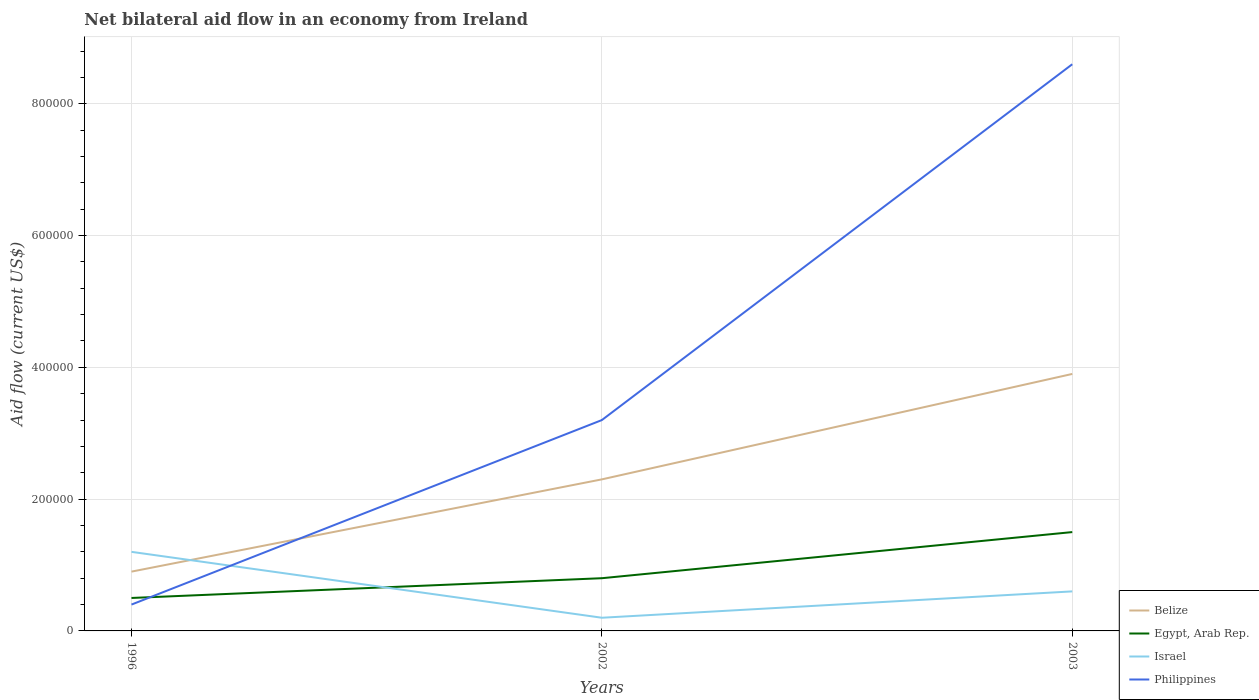Is the number of lines equal to the number of legend labels?
Offer a very short reply. Yes. What is the difference between the highest and the second highest net bilateral aid flow in Egypt, Arab Rep.?
Provide a succinct answer. 1.00e+05. What is the difference between the highest and the lowest net bilateral aid flow in Israel?
Ensure brevity in your answer.  1. How many lines are there?
Your answer should be compact. 4. Are the values on the major ticks of Y-axis written in scientific E-notation?
Ensure brevity in your answer.  No. Does the graph contain any zero values?
Make the answer very short. No. Does the graph contain grids?
Your response must be concise. Yes. How many legend labels are there?
Provide a short and direct response. 4. What is the title of the graph?
Give a very brief answer. Net bilateral aid flow in an economy from Ireland. Does "Caribbean small states" appear as one of the legend labels in the graph?
Make the answer very short. No. What is the Aid flow (current US$) in Philippines in 1996?
Keep it short and to the point. 4.00e+04. What is the Aid flow (current US$) of Egypt, Arab Rep. in 2002?
Ensure brevity in your answer.  8.00e+04. What is the Aid flow (current US$) of Israel in 2002?
Your answer should be compact. 2.00e+04. What is the Aid flow (current US$) in Belize in 2003?
Keep it short and to the point. 3.90e+05. What is the Aid flow (current US$) of Israel in 2003?
Provide a succinct answer. 6.00e+04. What is the Aid flow (current US$) in Philippines in 2003?
Your response must be concise. 8.60e+05. Across all years, what is the maximum Aid flow (current US$) of Belize?
Offer a very short reply. 3.90e+05. Across all years, what is the maximum Aid flow (current US$) of Egypt, Arab Rep.?
Offer a very short reply. 1.50e+05. Across all years, what is the maximum Aid flow (current US$) in Israel?
Offer a terse response. 1.20e+05. Across all years, what is the maximum Aid flow (current US$) in Philippines?
Offer a very short reply. 8.60e+05. Across all years, what is the minimum Aid flow (current US$) of Belize?
Your answer should be very brief. 9.00e+04. Across all years, what is the minimum Aid flow (current US$) in Israel?
Offer a very short reply. 2.00e+04. Across all years, what is the minimum Aid flow (current US$) of Philippines?
Your answer should be very brief. 4.00e+04. What is the total Aid flow (current US$) in Belize in the graph?
Provide a short and direct response. 7.10e+05. What is the total Aid flow (current US$) of Israel in the graph?
Give a very brief answer. 2.00e+05. What is the total Aid flow (current US$) in Philippines in the graph?
Make the answer very short. 1.22e+06. What is the difference between the Aid flow (current US$) in Israel in 1996 and that in 2002?
Your answer should be very brief. 1.00e+05. What is the difference between the Aid flow (current US$) of Philippines in 1996 and that in 2002?
Your answer should be compact. -2.80e+05. What is the difference between the Aid flow (current US$) in Egypt, Arab Rep. in 1996 and that in 2003?
Offer a terse response. -1.00e+05. What is the difference between the Aid flow (current US$) in Israel in 1996 and that in 2003?
Your answer should be very brief. 6.00e+04. What is the difference between the Aid flow (current US$) in Philippines in 1996 and that in 2003?
Offer a terse response. -8.20e+05. What is the difference between the Aid flow (current US$) in Belize in 2002 and that in 2003?
Provide a short and direct response. -1.60e+05. What is the difference between the Aid flow (current US$) in Philippines in 2002 and that in 2003?
Provide a short and direct response. -5.40e+05. What is the difference between the Aid flow (current US$) of Belize in 1996 and the Aid flow (current US$) of Egypt, Arab Rep. in 2002?
Provide a succinct answer. 10000. What is the difference between the Aid flow (current US$) in Belize in 1996 and the Aid flow (current US$) in Philippines in 2002?
Give a very brief answer. -2.30e+05. What is the difference between the Aid flow (current US$) of Egypt, Arab Rep. in 1996 and the Aid flow (current US$) of Philippines in 2002?
Offer a very short reply. -2.70e+05. What is the difference between the Aid flow (current US$) in Belize in 1996 and the Aid flow (current US$) in Egypt, Arab Rep. in 2003?
Give a very brief answer. -6.00e+04. What is the difference between the Aid flow (current US$) of Belize in 1996 and the Aid flow (current US$) of Philippines in 2003?
Offer a very short reply. -7.70e+05. What is the difference between the Aid flow (current US$) of Egypt, Arab Rep. in 1996 and the Aid flow (current US$) of Israel in 2003?
Keep it short and to the point. -10000. What is the difference between the Aid flow (current US$) of Egypt, Arab Rep. in 1996 and the Aid flow (current US$) of Philippines in 2003?
Provide a succinct answer. -8.10e+05. What is the difference between the Aid flow (current US$) in Israel in 1996 and the Aid flow (current US$) in Philippines in 2003?
Keep it short and to the point. -7.40e+05. What is the difference between the Aid flow (current US$) in Belize in 2002 and the Aid flow (current US$) in Israel in 2003?
Keep it short and to the point. 1.70e+05. What is the difference between the Aid flow (current US$) in Belize in 2002 and the Aid flow (current US$) in Philippines in 2003?
Provide a short and direct response. -6.30e+05. What is the difference between the Aid flow (current US$) of Egypt, Arab Rep. in 2002 and the Aid flow (current US$) of Israel in 2003?
Your answer should be very brief. 2.00e+04. What is the difference between the Aid flow (current US$) of Egypt, Arab Rep. in 2002 and the Aid flow (current US$) of Philippines in 2003?
Provide a succinct answer. -7.80e+05. What is the difference between the Aid flow (current US$) in Israel in 2002 and the Aid flow (current US$) in Philippines in 2003?
Make the answer very short. -8.40e+05. What is the average Aid flow (current US$) of Belize per year?
Provide a short and direct response. 2.37e+05. What is the average Aid flow (current US$) of Egypt, Arab Rep. per year?
Keep it short and to the point. 9.33e+04. What is the average Aid flow (current US$) of Israel per year?
Make the answer very short. 6.67e+04. What is the average Aid flow (current US$) in Philippines per year?
Offer a terse response. 4.07e+05. In the year 1996, what is the difference between the Aid flow (current US$) in Belize and Aid flow (current US$) in Egypt, Arab Rep.?
Give a very brief answer. 4.00e+04. In the year 1996, what is the difference between the Aid flow (current US$) in Egypt, Arab Rep. and Aid flow (current US$) in Israel?
Offer a very short reply. -7.00e+04. In the year 1996, what is the difference between the Aid flow (current US$) in Egypt, Arab Rep. and Aid flow (current US$) in Philippines?
Your answer should be very brief. 10000. In the year 2002, what is the difference between the Aid flow (current US$) in Belize and Aid flow (current US$) in Egypt, Arab Rep.?
Provide a succinct answer. 1.50e+05. In the year 2002, what is the difference between the Aid flow (current US$) in Belize and Aid flow (current US$) in Israel?
Your response must be concise. 2.10e+05. In the year 2002, what is the difference between the Aid flow (current US$) in Belize and Aid flow (current US$) in Philippines?
Your answer should be compact. -9.00e+04. In the year 2002, what is the difference between the Aid flow (current US$) of Egypt, Arab Rep. and Aid flow (current US$) of Israel?
Give a very brief answer. 6.00e+04. In the year 2002, what is the difference between the Aid flow (current US$) in Israel and Aid flow (current US$) in Philippines?
Offer a terse response. -3.00e+05. In the year 2003, what is the difference between the Aid flow (current US$) of Belize and Aid flow (current US$) of Egypt, Arab Rep.?
Offer a very short reply. 2.40e+05. In the year 2003, what is the difference between the Aid flow (current US$) of Belize and Aid flow (current US$) of Israel?
Provide a short and direct response. 3.30e+05. In the year 2003, what is the difference between the Aid flow (current US$) in Belize and Aid flow (current US$) in Philippines?
Provide a short and direct response. -4.70e+05. In the year 2003, what is the difference between the Aid flow (current US$) of Egypt, Arab Rep. and Aid flow (current US$) of Philippines?
Offer a very short reply. -7.10e+05. In the year 2003, what is the difference between the Aid flow (current US$) of Israel and Aid flow (current US$) of Philippines?
Your response must be concise. -8.00e+05. What is the ratio of the Aid flow (current US$) in Belize in 1996 to that in 2002?
Offer a very short reply. 0.39. What is the ratio of the Aid flow (current US$) of Israel in 1996 to that in 2002?
Your response must be concise. 6. What is the ratio of the Aid flow (current US$) in Belize in 1996 to that in 2003?
Your response must be concise. 0.23. What is the ratio of the Aid flow (current US$) of Egypt, Arab Rep. in 1996 to that in 2003?
Keep it short and to the point. 0.33. What is the ratio of the Aid flow (current US$) of Israel in 1996 to that in 2003?
Provide a short and direct response. 2. What is the ratio of the Aid flow (current US$) of Philippines in 1996 to that in 2003?
Your answer should be very brief. 0.05. What is the ratio of the Aid flow (current US$) in Belize in 2002 to that in 2003?
Make the answer very short. 0.59. What is the ratio of the Aid flow (current US$) of Egypt, Arab Rep. in 2002 to that in 2003?
Offer a terse response. 0.53. What is the ratio of the Aid flow (current US$) of Philippines in 2002 to that in 2003?
Provide a succinct answer. 0.37. What is the difference between the highest and the second highest Aid flow (current US$) in Belize?
Provide a short and direct response. 1.60e+05. What is the difference between the highest and the second highest Aid flow (current US$) of Egypt, Arab Rep.?
Make the answer very short. 7.00e+04. What is the difference between the highest and the second highest Aid flow (current US$) in Philippines?
Provide a short and direct response. 5.40e+05. What is the difference between the highest and the lowest Aid flow (current US$) of Belize?
Offer a very short reply. 3.00e+05. What is the difference between the highest and the lowest Aid flow (current US$) in Egypt, Arab Rep.?
Your answer should be compact. 1.00e+05. What is the difference between the highest and the lowest Aid flow (current US$) of Philippines?
Your answer should be compact. 8.20e+05. 